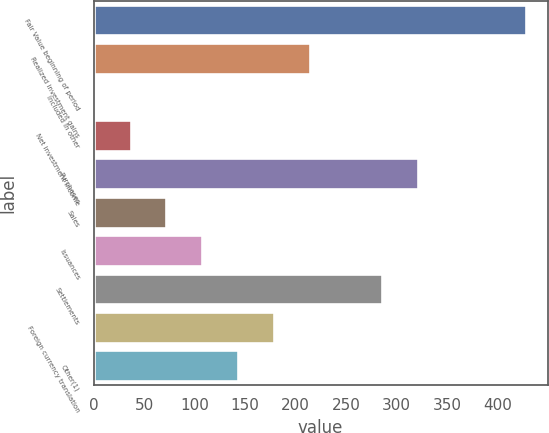Convert chart. <chart><loc_0><loc_0><loc_500><loc_500><bar_chart><fcel>Fair Value beginning of period<fcel>Realized investment gains<fcel>Included in other<fcel>Net investment income<fcel>Purchases<fcel>Sales<fcel>Issuances<fcel>Settlements<fcel>Foreign currency translation<fcel>Other(1)<nl><fcel>428.2<fcel>214.6<fcel>1<fcel>36.6<fcel>321.4<fcel>72.2<fcel>107.8<fcel>285.8<fcel>179<fcel>143.4<nl></chart> 